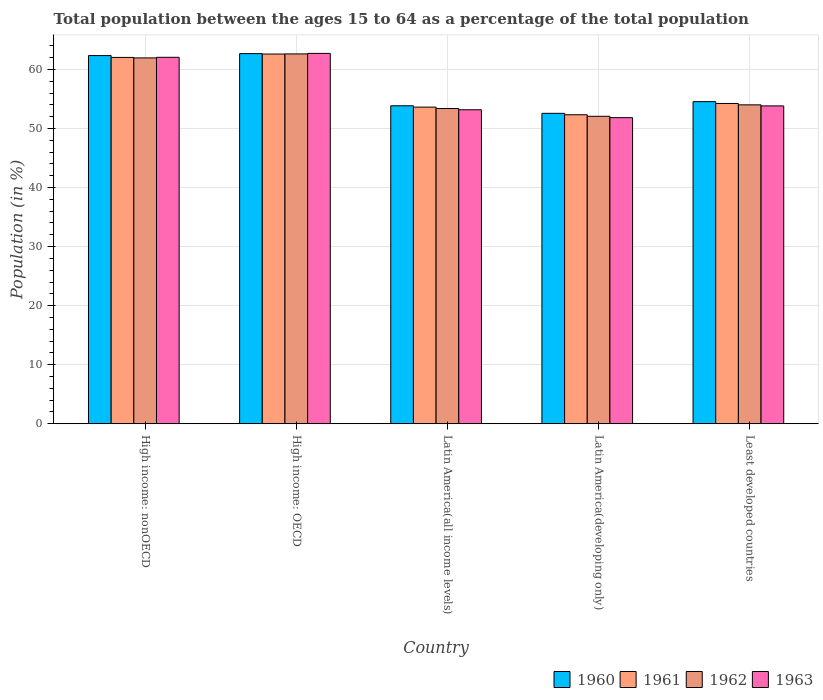How many bars are there on the 4th tick from the left?
Your response must be concise. 4. What is the label of the 2nd group of bars from the left?
Keep it short and to the point. High income: OECD. What is the percentage of the population ages 15 to 64 in 1961 in Latin America(developing only)?
Your response must be concise. 52.32. Across all countries, what is the maximum percentage of the population ages 15 to 64 in 1963?
Your response must be concise. 62.71. Across all countries, what is the minimum percentage of the population ages 15 to 64 in 1961?
Make the answer very short. 52.32. In which country was the percentage of the population ages 15 to 64 in 1963 maximum?
Provide a succinct answer. High income: OECD. In which country was the percentage of the population ages 15 to 64 in 1960 minimum?
Offer a terse response. Latin America(developing only). What is the total percentage of the population ages 15 to 64 in 1962 in the graph?
Ensure brevity in your answer.  284.02. What is the difference between the percentage of the population ages 15 to 64 in 1962 in High income: OECD and that in Latin America(developing only)?
Ensure brevity in your answer.  10.56. What is the difference between the percentage of the population ages 15 to 64 in 1962 in Latin America(developing only) and the percentage of the population ages 15 to 64 in 1960 in High income: OECD?
Make the answer very short. -10.61. What is the average percentage of the population ages 15 to 64 in 1962 per country?
Your answer should be very brief. 56.8. What is the difference between the percentage of the population ages 15 to 64 of/in 1960 and percentage of the population ages 15 to 64 of/in 1963 in High income: OECD?
Your response must be concise. -0.04. What is the ratio of the percentage of the population ages 15 to 64 in 1962 in High income: OECD to that in High income: nonOECD?
Your answer should be very brief. 1.01. What is the difference between the highest and the second highest percentage of the population ages 15 to 64 in 1960?
Ensure brevity in your answer.  7.8. What is the difference between the highest and the lowest percentage of the population ages 15 to 64 in 1960?
Give a very brief answer. 10.11. Is the sum of the percentage of the population ages 15 to 64 in 1962 in High income: OECD and Latin America(developing only) greater than the maximum percentage of the population ages 15 to 64 in 1961 across all countries?
Keep it short and to the point. Yes. Is it the case that in every country, the sum of the percentage of the population ages 15 to 64 in 1960 and percentage of the population ages 15 to 64 in 1963 is greater than the sum of percentage of the population ages 15 to 64 in 1961 and percentage of the population ages 15 to 64 in 1962?
Give a very brief answer. No. What does the 2nd bar from the right in Latin America(all income levels) represents?
Ensure brevity in your answer.  1962. Is it the case that in every country, the sum of the percentage of the population ages 15 to 64 in 1961 and percentage of the population ages 15 to 64 in 1962 is greater than the percentage of the population ages 15 to 64 in 1963?
Your answer should be very brief. Yes. How many bars are there?
Offer a terse response. 20. Are all the bars in the graph horizontal?
Your answer should be very brief. No. How many countries are there in the graph?
Provide a short and direct response. 5. How many legend labels are there?
Offer a very short reply. 4. What is the title of the graph?
Your answer should be very brief. Total population between the ages 15 to 64 as a percentage of the total population. What is the Population (in %) of 1960 in High income: nonOECD?
Make the answer very short. 62.34. What is the Population (in %) of 1961 in High income: nonOECD?
Make the answer very short. 62.03. What is the Population (in %) of 1962 in High income: nonOECD?
Offer a very short reply. 61.95. What is the Population (in %) of 1963 in High income: nonOECD?
Keep it short and to the point. 62.05. What is the Population (in %) in 1960 in High income: OECD?
Provide a succinct answer. 62.68. What is the Population (in %) of 1961 in High income: OECD?
Your response must be concise. 62.61. What is the Population (in %) in 1962 in High income: OECD?
Make the answer very short. 62.63. What is the Population (in %) of 1963 in High income: OECD?
Offer a terse response. 62.71. What is the Population (in %) in 1960 in Latin America(all income levels)?
Give a very brief answer. 53.84. What is the Population (in %) in 1961 in Latin America(all income levels)?
Keep it short and to the point. 53.62. What is the Population (in %) in 1962 in Latin America(all income levels)?
Your answer should be very brief. 53.38. What is the Population (in %) in 1963 in Latin America(all income levels)?
Offer a very short reply. 53.17. What is the Population (in %) in 1960 in Latin America(developing only)?
Ensure brevity in your answer.  52.56. What is the Population (in %) of 1961 in Latin America(developing only)?
Your answer should be compact. 52.32. What is the Population (in %) of 1962 in Latin America(developing only)?
Your answer should be very brief. 52.06. What is the Population (in %) of 1963 in Latin America(developing only)?
Offer a very short reply. 51.83. What is the Population (in %) of 1960 in Least developed countries?
Offer a very short reply. 54.54. What is the Population (in %) in 1961 in Least developed countries?
Provide a succinct answer. 54.24. What is the Population (in %) of 1962 in Least developed countries?
Offer a very short reply. 54. What is the Population (in %) of 1963 in Least developed countries?
Keep it short and to the point. 53.82. Across all countries, what is the maximum Population (in %) in 1960?
Give a very brief answer. 62.68. Across all countries, what is the maximum Population (in %) in 1961?
Offer a terse response. 62.61. Across all countries, what is the maximum Population (in %) of 1962?
Your response must be concise. 62.63. Across all countries, what is the maximum Population (in %) of 1963?
Your response must be concise. 62.71. Across all countries, what is the minimum Population (in %) in 1960?
Your response must be concise. 52.56. Across all countries, what is the minimum Population (in %) in 1961?
Keep it short and to the point. 52.32. Across all countries, what is the minimum Population (in %) of 1962?
Ensure brevity in your answer.  52.06. Across all countries, what is the minimum Population (in %) of 1963?
Give a very brief answer. 51.83. What is the total Population (in %) of 1960 in the graph?
Your answer should be compact. 285.97. What is the total Population (in %) of 1961 in the graph?
Make the answer very short. 284.81. What is the total Population (in %) in 1962 in the graph?
Your answer should be very brief. 284.02. What is the total Population (in %) in 1963 in the graph?
Ensure brevity in your answer.  283.59. What is the difference between the Population (in %) in 1960 in High income: nonOECD and that in High income: OECD?
Offer a terse response. -0.33. What is the difference between the Population (in %) of 1961 in High income: nonOECD and that in High income: OECD?
Ensure brevity in your answer.  -0.58. What is the difference between the Population (in %) in 1962 in High income: nonOECD and that in High income: OECD?
Keep it short and to the point. -0.68. What is the difference between the Population (in %) in 1963 in High income: nonOECD and that in High income: OECD?
Your answer should be very brief. -0.66. What is the difference between the Population (in %) in 1960 in High income: nonOECD and that in Latin America(all income levels)?
Give a very brief answer. 8.5. What is the difference between the Population (in %) in 1961 in High income: nonOECD and that in Latin America(all income levels)?
Your response must be concise. 8.41. What is the difference between the Population (in %) in 1962 in High income: nonOECD and that in Latin America(all income levels)?
Provide a succinct answer. 8.57. What is the difference between the Population (in %) in 1963 in High income: nonOECD and that in Latin America(all income levels)?
Provide a succinct answer. 8.89. What is the difference between the Population (in %) in 1960 in High income: nonOECD and that in Latin America(developing only)?
Provide a succinct answer. 9.78. What is the difference between the Population (in %) of 1961 in High income: nonOECD and that in Latin America(developing only)?
Offer a very short reply. 9.71. What is the difference between the Population (in %) of 1962 in High income: nonOECD and that in Latin America(developing only)?
Make the answer very short. 9.89. What is the difference between the Population (in %) in 1963 in High income: nonOECD and that in Latin America(developing only)?
Keep it short and to the point. 10.22. What is the difference between the Population (in %) in 1960 in High income: nonOECD and that in Least developed countries?
Give a very brief answer. 7.8. What is the difference between the Population (in %) of 1961 in High income: nonOECD and that in Least developed countries?
Offer a very short reply. 7.79. What is the difference between the Population (in %) in 1962 in High income: nonOECD and that in Least developed countries?
Provide a succinct answer. 7.95. What is the difference between the Population (in %) in 1963 in High income: nonOECD and that in Least developed countries?
Keep it short and to the point. 8.23. What is the difference between the Population (in %) in 1960 in High income: OECD and that in Latin America(all income levels)?
Offer a very short reply. 8.83. What is the difference between the Population (in %) in 1961 in High income: OECD and that in Latin America(all income levels)?
Give a very brief answer. 8.99. What is the difference between the Population (in %) of 1962 in High income: OECD and that in Latin America(all income levels)?
Your answer should be compact. 9.25. What is the difference between the Population (in %) of 1963 in High income: OECD and that in Latin America(all income levels)?
Make the answer very short. 9.55. What is the difference between the Population (in %) in 1960 in High income: OECD and that in Latin America(developing only)?
Provide a short and direct response. 10.11. What is the difference between the Population (in %) of 1961 in High income: OECD and that in Latin America(developing only)?
Offer a terse response. 10.28. What is the difference between the Population (in %) of 1962 in High income: OECD and that in Latin America(developing only)?
Offer a very short reply. 10.56. What is the difference between the Population (in %) in 1963 in High income: OECD and that in Latin America(developing only)?
Make the answer very short. 10.88. What is the difference between the Population (in %) in 1960 in High income: OECD and that in Least developed countries?
Keep it short and to the point. 8.14. What is the difference between the Population (in %) in 1961 in High income: OECD and that in Least developed countries?
Make the answer very short. 8.37. What is the difference between the Population (in %) of 1962 in High income: OECD and that in Least developed countries?
Provide a short and direct response. 8.63. What is the difference between the Population (in %) of 1963 in High income: OECD and that in Least developed countries?
Your response must be concise. 8.89. What is the difference between the Population (in %) in 1960 in Latin America(all income levels) and that in Latin America(developing only)?
Ensure brevity in your answer.  1.28. What is the difference between the Population (in %) of 1961 in Latin America(all income levels) and that in Latin America(developing only)?
Make the answer very short. 1.3. What is the difference between the Population (in %) in 1962 in Latin America(all income levels) and that in Latin America(developing only)?
Keep it short and to the point. 1.32. What is the difference between the Population (in %) in 1963 in Latin America(all income levels) and that in Latin America(developing only)?
Provide a short and direct response. 1.33. What is the difference between the Population (in %) of 1960 in Latin America(all income levels) and that in Least developed countries?
Provide a short and direct response. -0.7. What is the difference between the Population (in %) in 1961 in Latin America(all income levels) and that in Least developed countries?
Your answer should be compact. -0.62. What is the difference between the Population (in %) in 1962 in Latin America(all income levels) and that in Least developed countries?
Keep it short and to the point. -0.62. What is the difference between the Population (in %) in 1963 in Latin America(all income levels) and that in Least developed countries?
Provide a short and direct response. -0.66. What is the difference between the Population (in %) in 1960 in Latin America(developing only) and that in Least developed countries?
Ensure brevity in your answer.  -1.98. What is the difference between the Population (in %) of 1961 in Latin America(developing only) and that in Least developed countries?
Offer a terse response. -1.91. What is the difference between the Population (in %) in 1962 in Latin America(developing only) and that in Least developed countries?
Your response must be concise. -1.94. What is the difference between the Population (in %) in 1963 in Latin America(developing only) and that in Least developed countries?
Provide a short and direct response. -1.99. What is the difference between the Population (in %) in 1960 in High income: nonOECD and the Population (in %) in 1961 in High income: OECD?
Give a very brief answer. -0.26. What is the difference between the Population (in %) in 1960 in High income: nonOECD and the Population (in %) in 1962 in High income: OECD?
Your response must be concise. -0.28. What is the difference between the Population (in %) in 1960 in High income: nonOECD and the Population (in %) in 1963 in High income: OECD?
Your answer should be very brief. -0.37. What is the difference between the Population (in %) of 1961 in High income: nonOECD and the Population (in %) of 1962 in High income: OECD?
Keep it short and to the point. -0.6. What is the difference between the Population (in %) of 1961 in High income: nonOECD and the Population (in %) of 1963 in High income: OECD?
Make the answer very short. -0.68. What is the difference between the Population (in %) of 1962 in High income: nonOECD and the Population (in %) of 1963 in High income: OECD?
Provide a succinct answer. -0.76. What is the difference between the Population (in %) in 1960 in High income: nonOECD and the Population (in %) in 1961 in Latin America(all income levels)?
Ensure brevity in your answer.  8.73. What is the difference between the Population (in %) in 1960 in High income: nonOECD and the Population (in %) in 1962 in Latin America(all income levels)?
Your answer should be very brief. 8.96. What is the difference between the Population (in %) in 1960 in High income: nonOECD and the Population (in %) in 1963 in Latin America(all income levels)?
Offer a terse response. 9.18. What is the difference between the Population (in %) in 1961 in High income: nonOECD and the Population (in %) in 1962 in Latin America(all income levels)?
Your response must be concise. 8.65. What is the difference between the Population (in %) in 1961 in High income: nonOECD and the Population (in %) in 1963 in Latin America(all income levels)?
Make the answer very short. 8.86. What is the difference between the Population (in %) in 1962 in High income: nonOECD and the Population (in %) in 1963 in Latin America(all income levels)?
Ensure brevity in your answer.  8.78. What is the difference between the Population (in %) in 1960 in High income: nonOECD and the Population (in %) in 1961 in Latin America(developing only)?
Your response must be concise. 10.02. What is the difference between the Population (in %) of 1960 in High income: nonOECD and the Population (in %) of 1962 in Latin America(developing only)?
Your answer should be very brief. 10.28. What is the difference between the Population (in %) in 1960 in High income: nonOECD and the Population (in %) in 1963 in Latin America(developing only)?
Keep it short and to the point. 10.51. What is the difference between the Population (in %) in 1961 in High income: nonOECD and the Population (in %) in 1962 in Latin America(developing only)?
Give a very brief answer. 9.97. What is the difference between the Population (in %) of 1961 in High income: nonOECD and the Population (in %) of 1963 in Latin America(developing only)?
Give a very brief answer. 10.2. What is the difference between the Population (in %) in 1962 in High income: nonOECD and the Population (in %) in 1963 in Latin America(developing only)?
Your answer should be very brief. 10.12. What is the difference between the Population (in %) in 1960 in High income: nonOECD and the Population (in %) in 1961 in Least developed countries?
Make the answer very short. 8.11. What is the difference between the Population (in %) in 1960 in High income: nonOECD and the Population (in %) in 1962 in Least developed countries?
Keep it short and to the point. 8.34. What is the difference between the Population (in %) of 1960 in High income: nonOECD and the Population (in %) of 1963 in Least developed countries?
Your answer should be compact. 8.52. What is the difference between the Population (in %) in 1961 in High income: nonOECD and the Population (in %) in 1962 in Least developed countries?
Your response must be concise. 8.03. What is the difference between the Population (in %) in 1961 in High income: nonOECD and the Population (in %) in 1963 in Least developed countries?
Provide a short and direct response. 8.21. What is the difference between the Population (in %) in 1962 in High income: nonOECD and the Population (in %) in 1963 in Least developed countries?
Offer a terse response. 8.13. What is the difference between the Population (in %) in 1960 in High income: OECD and the Population (in %) in 1961 in Latin America(all income levels)?
Ensure brevity in your answer.  9.06. What is the difference between the Population (in %) in 1960 in High income: OECD and the Population (in %) in 1962 in Latin America(all income levels)?
Keep it short and to the point. 9.3. What is the difference between the Population (in %) of 1960 in High income: OECD and the Population (in %) of 1963 in Latin America(all income levels)?
Provide a short and direct response. 9.51. What is the difference between the Population (in %) in 1961 in High income: OECD and the Population (in %) in 1962 in Latin America(all income levels)?
Make the answer very short. 9.23. What is the difference between the Population (in %) in 1961 in High income: OECD and the Population (in %) in 1963 in Latin America(all income levels)?
Offer a very short reply. 9.44. What is the difference between the Population (in %) of 1962 in High income: OECD and the Population (in %) of 1963 in Latin America(all income levels)?
Make the answer very short. 9.46. What is the difference between the Population (in %) in 1960 in High income: OECD and the Population (in %) in 1961 in Latin America(developing only)?
Your answer should be compact. 10.35. What is the difference between the Population (in %) in 1960 in High income: OECD and the Population (in %) in 1962 in Latin America(developing only)?
Your response must be concise. 10.61. What is the difference between the Population (in %) of 1960 in High income: OECD and the Population (in %) of 1963 in Latin America(developing only)?
Your answer should be very brief. 10.85. What is the difference between the Population (in %) of 1961 in High income: OECD and the Population (in %) of 1962 in Latin America(developing only)?
Your response must be concise. 10.54. What is the difference between the Population (in %) in 1961 in High income: OECD and the Population (in %) in 1963 in Latin America(developing only)?
Your answer should be very brief. 10.77. What is the difference between the Population (in %) in 1962 in High income: OECD and the Population (in %) in 1963 in Latin America(developing only)?
Provide a succinct answer. 10.79. What is the difference between the Population (in %) in 1960 in High income: OECD and the Population (in %) in 1961 in Least developed countries?
Your answer should be very brief. 8.44. What is the difference between the Population (in %) of 1960 in High income: OECD and the Population (in %) of 1962 in Least developed countries?
Offer a terse response. 8.68. What is the difference between the Population (in %) of 1960 in High income: OECD and the Population (in %) of 1963 in Least developed countries?
Keep it short and to the point. 8.85. What is the difference between the Population (in %) of 1961 in High income: OECD and the Population (in %) of 1962 in Least developed countries?
Make the answer very short. 8.61. What is the difference between the Population (in %) of 1961 in High income: OECD and the Population (in %) of 1963 in Least developed countries?
Your response must be concise. 8.78. What is the difference between the Population (in %) of 1962 in High income: OECD and the Population (in %) of 1963 in Least developed countries?
Your answer should be very brief. 8.8. What is the difference between the Population (in %) of 1960 in Latin America(all income levels) and the Population (in %) of 1961 in Latin America(developing only)?
Keep it short and to the point. 1.52. What is the difference between the Population (in %) of 1960 in Latin America(all income levels) and the Population (in %) of 1962 in Latin America(developing only)?
Give a very brief answer. 1.78. What is the difference between the Population (in %) of 1960 in Latin America(all income levels) and the Population (in %) of 1963 in Latin America(developing only)?
Keep it short and to the point. 2.01. What is the difference between the Population (in %) in 1961 in Latin America(all income levels) and the Population (in %) in 1962 in Latin America(developing only)?
Provide a succinct answer. 1.55. What is the difference between the Population (in %) of 1961 in Latin America(all income levels) and the Population (in %) of 1963 in Latin America(developing only)?
Give a very brief answer. 1.79. What is the difference between the Population (in %) of 1962 in Latin America(all income levels) and the Population (in %) of 1963 in Latin America(developing only)?
Your response must be concise. 1.55. What is the difference between the Population (in %) in 1960 in Latin America(all income levels) and the Population (in %) in 1961 in Least developed countries?
Provide a succinct answer. -0.39. What is the difference between the Population (in %) of 1960 in Latin America(all income levels) and the Population (in %) of 1962 in Least developed countries?
Keep it short and to the point. -0.16. What is the difference between the Population (in %) in 1960 in Latin America(all income levels) and the Population (in %) in 1963 in Least developed countries?
Ensure brevity in your answer.  0.02. What is the difference between the Population (in %) of 1961 in Latin America(all income levels) and the Population (in %) of 1962 in Least developed countries?
Provide a succinct answer. -0.38. What is the difference between the Population (in %) of 1961 in Latin America(all income levels) and the Population (in %) of 1963 in Least developed countries?
Provide a succinct answer. -0.2. What is the difference between the Population (in %) in 1962 in Latin America(all income levels) and the Population (in %) in 1963 in Least developed countries?
Your response must be concise. -0.44. What is the difference between the Population (in %) of 1960 in Latin America(developing only) and the Population (in %) of 1961 in Least developed countries?
Offer a terse response. -1.67. What is the difference between the Population (in %) in 1960 in Latin America(developing only) and the Population (in %) in 1962 in Least developed countries?
Keep it short and to the point. -1.44. What is the difference between the Population (in %) of 1960 in Latin America(developing only) and the Population (in %) of 1963 in Least developed countries?
Offer a very short reply. -1.26. What is the difference between the Population (in %) in 1961 in Latin America(developing only) and the Population (in %) in 1962 in Least developed countries?
Provide a short and direct response. -1.68. What is the difference between the Population (in %) of 1961 in Latin America(developing only) and the Population (in %) of 1963 in Least developed countries?
Make the answer very short. -1.5. What is the difference between the Population (in %) of 1962 in Latin America(developing only) and the Population (in %) of 1963 in Least developed countries?
Make the answer very short. -1.76. What is the average Population (in %) in 1960 per country?
Your answer should be very brief. 57.19. What is the average Population (in %) of 1961 per country?
Your answer should be compact. 56.96. What is the average Population (in %) in 1962 per country?
Offer a very short reply. 56.8. What is the average Population (in %) in 1963 per country?
Make the answer very short. 56.72. What is the difference between the Population (in %) in 1960 and Population (in %) in 1961 in High income: nonOECD?
Offer a terse response. 0.31. What is the difference between the Population (in %) of 1960 and Population (in %) of 1962 in High income: nonOECD?
Keep it short and to the point. 0.39. What is the difference between the Population (in %) in 1960 and Population (in %) in 1963 in High income: nonOECD?
Your response must be concise. 0.29. What is the difference between the Population (in %) in 1961 and Population (in %) in 1962 in High income: nonOECD?
Your answer should be compact. 0.08. What is the difference between the Population (in %) of 1961 and Population (in %) of 1963 in High income: nonOECD?
Ensure brevity in your answer.  -0.02. What is the difference between the Population (in %) of 1962 and Population (in %) of 1963 in High income: nonOECD?
Provide a succinct answer. -0.1. What is the difference between the Population (in %) in 1960 and Population (in %) in 1961 in High income: OECD?
Your answer should be very brief. 0.07. What is the difference between the Population (in %) in 1960 and Population (in %) in 1962 in High income: OECD?
Make the answer very short. 0.05. What is the difference between the Population (in %) in 1960 and Population (in %) in 1963 in High income: OECD?
Provide a succinct answer. -0.04. What is the difference between the Population (in %) in 1961 and Population (in %) in 1962 in High income: OECD?
Offer a terse response. -0.02. What is the difference between the Population (in %) in 1961 and Population (in %) in 1963 in High income: OECD?
Provide a succinct answer. -0.11. What is the difference between the Population (in %) in 1962 and Population (in %) in 1963 in High income: OECD?
Provide a succinct answer. -0.09. What is the difference between the Population (in %) in 1960 and Population (in %) in 1961 in Latin America(all income levels)?
Ensure brevity in your answer.  0.23. What is the difference between the Population (in %) of 1960 and Population (in %) of 1962 in Latin America(all income levels)?
Your response must be concise. 0.47. What is the difference between the Population (in %) of 1960 and Population (in %) of 1963 in Latin America(all income levels)?
Your response must be concise. 0.68. What is the difference between the Population (in %) in 1961 and Population (in %) in 1962 in Latin America(all income levels)?
Ensure brevity in your answer.  0.24. What is the difference between the Population (in %) in 1961 and Population (in %) in 1963 in Latin America(all income levels)?
Offer a terse response. 0.45. What is the difference between the Population (in %) in 1962 and Population (in %) in 1963 in Latin America(all income levels)?
Make the answer very short. 0.21. What is the difference between the Population (in %) of 1960 and Population (in %) of 1961 in Latin America(developing only)?
Offer a very short reply. 0.24. What is the difference between the Population (in %) in 1960 and Population (in %) in 1962 in Latin America(developing only)?
Make the answer very short. 0.5. What is the difference between the Population (in %) of 1960 and Population (in %) of 1963 in Latin America(developing only)?
Give a very brief answer. 0.73. What is the difference between the Population (in %) in 1961 and Population (in %) in 1962 in Latin America(developing only)?
Your answer should be compact. 0.26. What is the difference between the Population (in %) in 1961 and Population (in %) in 1963 in Latin America(developing only)?
Ensure brevity in your answer.  0.49. What is the difference between the Population (in %) of 1962 and Population (in %) of 1963 in Latin America(developing only)?
Offer a terse response. 0.23. What is the difference between the Population (in %) of 1960 and Population (in %) of 1961 in Least developed countries?
Give a very brief answer. 0.31. What is the difference between the Population (in %) of 1960 and Population (in %) of 1962 in Least developed countries?
Provide a short and direct response. 0.54. What is the difference between the Population (in %) in 1960 and Population (in %) in 1963 in Least developed countries?
Ensure brevity in your answer.  0.72. What is the difference between the Population (in %) of 1961 and Population (in %) of 1962 in Least developed countries?
Give a very brief answer. 0.24. What is the difference between the Population (in %) in 1961 and Population (in %) in 1963 in Least developed countries?
Give a very brief answer. 0.41. What is the difference between the Population (in %) of 1962 and Population (in %) of 1963 in Least developed countries?
Provide a succinct answer. 0.18. What is the ratio of the Population (in %) in 1961 in High income: nonOECD to that in High income: OECD?
Offer a terse response. 0.99. What is the ratio of the Population (in %) of 1962 in High income: nonOECD to that in High income: OECD?
Make the answer very short. 0.99. What is the ratio of the Population (in %) of 1963 in High income: nonOECD to that in High income: OECD?
Offer a very short reply. 0.99. What is the ratio of the Population (in %) of 1960 in High income: nonOECD to that in Latin America(all income levels)?
Provide a short and direct response. 1.16. What is the ratio of the Population (in %) in 1961 in High income: nonOECD to that in Latin America(all income levels)?
Ensure brevity in your answer.  1.16. What is the ratio of the Population (in %) in 1962 in High income: nonOECD to that in Latin America(all income levels)?
Offer a terse response. 1.16. What is the ratio of the Population (in %) in 1963 in High income: nonOECD to that in Latin America(all income levels)?
Your answer should be compact. 1.17. What is the ratio of the Population (in %) of 1960 in High income: nonOECD to that in Latin America(developing only)?
Your answer should be very brief. 1.19. What is the ratio of the Population (in %) of 1961 in High income: nonOECD to that in Latin America(developing only)?
Make the answer very short. 1.19. What is the ratio of the Population (in %) in 1962 in High income: nonOECD to that in Latin America(developing only)?
Keep it short and to the point. 1.19. What is the ratio of the Population (in %) of 1963 in High income: nonOECD to that in Latin America(developing only)?
Give a very brief answer. 1.2. What is the ratio of the Population (in %) of 1960 in High income: nonOECD to that in Least developed countries?
Keep it short and to the point. 1.14. What is the ratio of the Population (in %) in 1961 in High income: nonOECD to that in Least developed countries?
Keep it short and to the point. 1.14. What is the ratio of the Population (in %) in 1962 in High income: nonOECD to that in Least developed countries?
Keep it short and to the point. 1.15. What is the ratio of the Population (in %) in 1963 in High income: nonOECD to that in Least developed countries?
Provide a succinct answer. 1.15. What is the ratio of the Population (in %) in 1960 in High income: OECD to that in Latin America(all income levels)?
Ensure brevity in your answer.  1.16. What is the ratio of the Population (in %) of 1961 in High income: OECD to that in Latin America(all income levels)?
Provide a succinct answer. 1.17. What is the ratio of the Population (in %) in 1962 in High income: OECD to that in Latin America(all income levels)?
Provide a short and direct response. 1.17. What is the ratio of the Population (in %) in 1963 in High income: OECD to that in Latin America(all income levels)?
Keep it short and to the point. 1.18. What is the ratio of the Population (in %) in 1960 in High income: OECD to that in Latin America(developing only)?
Provide a succinct answer. 1.19. What is the ratio of the Population (in %) in 1961 in High income: OECD to that in Latin America(developing only)?
Offer a terse response. 1.2. What is the ratio of the Population (in %) in 1962 in High income: OECD to that in Latin America(developing only)?
Your answer should be very brief. 1.2. What is the ratio of the Population (in %) of 1963 in High income: OECD to that in Latin America(developing only)?
Offer a terse response. 1.21. What is the ratio of the Population (in %) in 1960 in High income: OECD to that in Least developed countries?
Your response must be concise. 1.15. What is the ratio of the Population (in %) in 1961 in High income: OECD to that in Least developed countries?
Keep it short and to the point. 1.15. What is the ratio of the Population (in %) in 1962 in High income: OECD to that in Least developed countries?
Provide a succinct answer. 1.16. What is the ratio of the Population (in %) of 1963 in High income: OECD to that in Least developed countries?
Your answer should be compact. 1.17. What is the ratio of the Population (in %) of 1960 in Latin America(all income levels) to that in Latin America(developing only)?
Your answer should be very brief. 1.02. What is the ratio of the Population (in %) in 1961 in Latin America(all income levels) to that in Latin America(developing only)?
Offer a terse response. 1.02. What is the ratio of the Population (in %) in 1962 in Latin America(all income levels) to that in Latin America(developing only)?
Your answer should be very brief. 1.03. What is the ratio of the Population (in %) in 1963 in Latin America(all income levels) to that in Latin America(developing only)?
Your answer should be compact. 1.03. What is the ratio of the Population (in %) of 1960 in Latin America(all income levels) to that in Least developed countries?
Give a very brief answer. 0.99. What is the ratio of the Population (in %) in 1961 in Latin America(all income levels) to that in Least developed countries?
Your response must be concise. 0.99. What is the ratio of the Population (in %) of 1962 in Latin America(all income levels) to that in Least developed countries?
Your response must be concise. 0.99. What is the ratio of the Population (in %) of 1960 in Latin America(developing only) to that in Least developed countries?
Provide a succinct answer. 0.96. What is the ratio of the Population (in %) in 1961 in Latin America(developing only) to that in Least developed countries?
Offer a terse response. 0.96. What is the ratio of the Population (in %) of 1962 in Latin America(developing only) to that in Least developed countries?
Provide a short and direct response. 0.96. What is the difference between the highest and the second highest Population (in %) in 1960?
Keep it short and to the point. 0.33. What is the difference between the highest and the second highest Population (in %) of 1961?
Your answer should be compact. 0.58. What is the difference between the highest and the second highest Population (in %) in 1962?
Your answer should be very brief. 0.68. What is the difference between the highest and the second highest Population (in %) of 1963?
Your response must be concise. 0.66. What is the difference between the highest and the lowest Population (in %) of 1960?
Your answer should be compact. 10.11. What is the difference between the highest and the lowest Population (in %) in 1961?
Provide a succinct answer. 10.28. What is the difference between the highest and the lowest Population (in %) of 1962?
Ensure brevity in your answer.  10.56. What is the difference between the highest and the lowest Population (in %) of 1963?
Give a very brief answer. 10.88. 